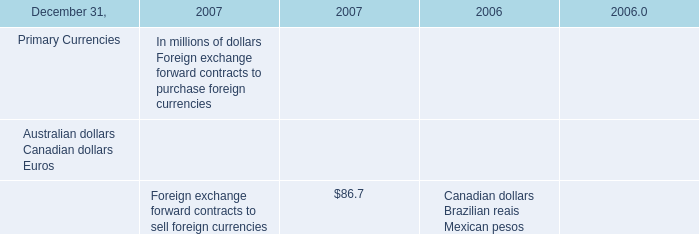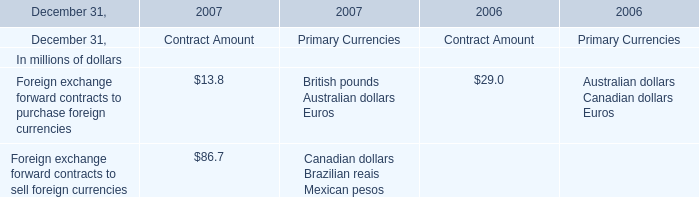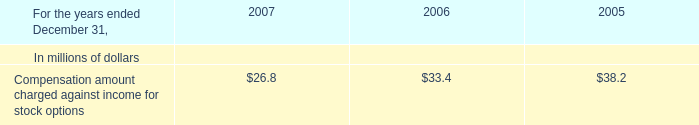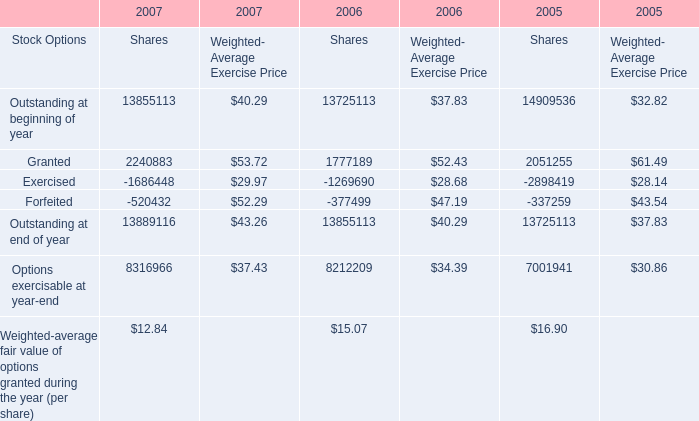Does the proportion of Outstanding at beginning of year for Shares in total larger than that of Granted in 2007? 
Answer: Yes. 